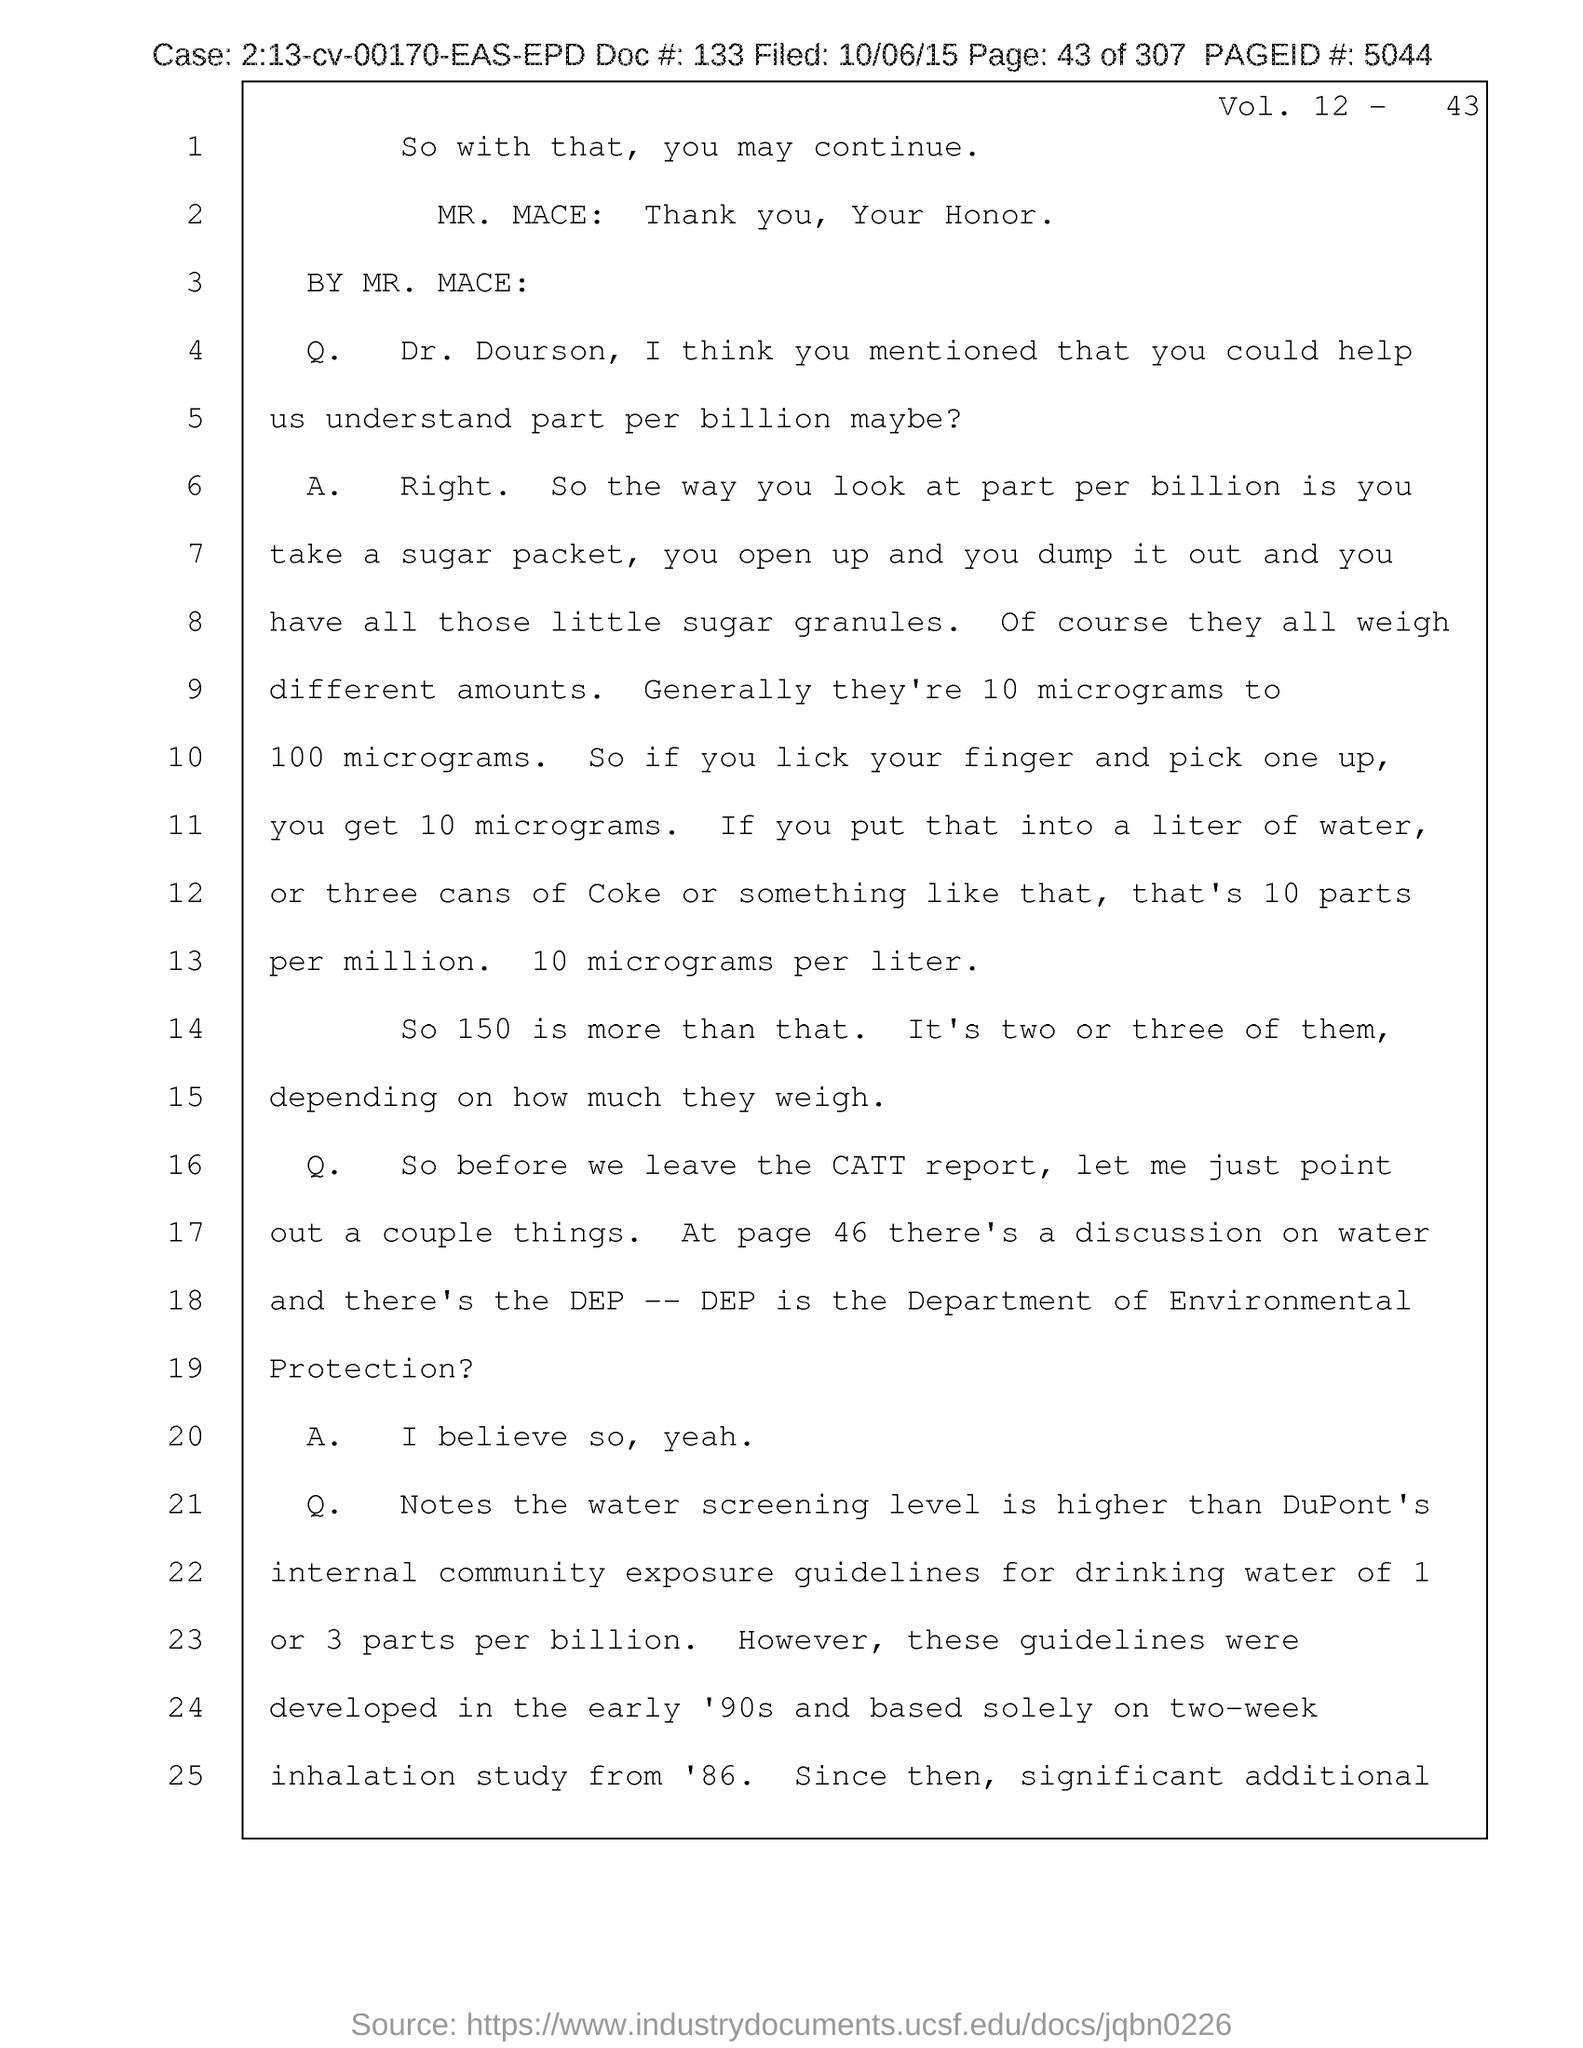What is the name of the person mentioned in the document starting with letter"M"?
Offer a very short reply. Mr. Mace. 